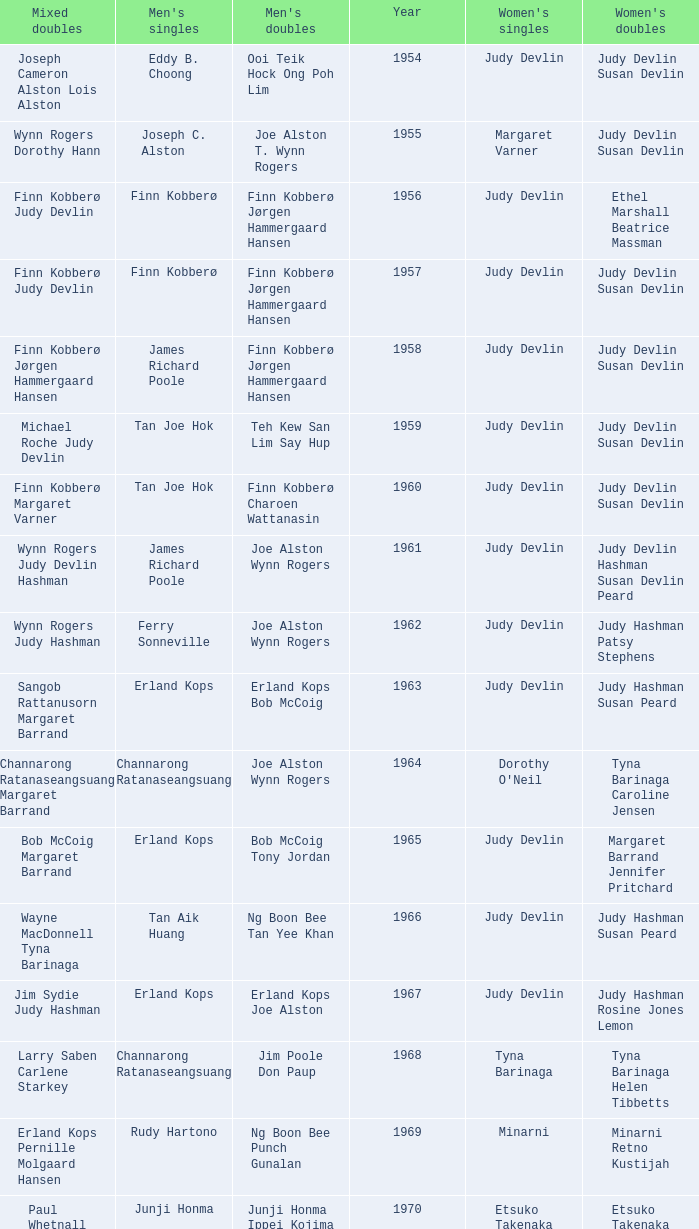Who was the women's singles champion in 1984? Luo Yun. Could you parse the entire table? {'header': ['Mixed doubles', "Men's singles", "Men's doubles", 'Year', "Women's singles", "Women's doubles"], 'rows': [['Joseph Cameron Alston Lois Alston', 'Eddy B. Choong', 'Ooi Teik Hock Ong Poh Lim', '1954', 'Judy Devlin', 'Judy Devlin Susan Devlin'], ['Wynn Rogers Dorothy Hann', 'Joseph C. Alston', 'Joe Alston T. Wynn Rogers', '1955', 'Margaret Varner', 'Judy Devlin Susan Devlin'], ['Finn Kobberø Judy Devlin', 'Finn Kobberø', 'Finn Kobberø Jørgen Hammergaard Hansen', '1956', 'Judy Devlin', 'Ethel Marshall Beatrice Massman'], ['Finn Kobberø Judy Devlin', 'Finn Kobberø', 'Finn Kobberø Jørgen Hammergaard Hansen', '1957', 'Judy Devlin', 'Judy Devlin Susan Devlin'], ['Finn Kobberø Jørgen Hammergaard Hansen', 'James Richard Poole', 'Finn Kobberø Jørgen Hammergaard Hansen', '1958', 'Judy Devlin', 'Judy Devlin Susan Devlin'], ['Michael Roche Judy Devlin', 'Tan Joe Hok', 'Teh Kew San Lim Say Hup', '1959', 'Judy Devlin', 'Judy Devlin Susan Devlin'], ['Finn Kobberø Margaret Varner', 'Tan Joe Hok', 'Finn Kobberø Charoen Wattanasin', '1960', 'Judy Devlin', 'Judy Devlin Susan Devlin'], ['Wynn Rogers Judy Devlin Hashman', 'James Richard Poole', 'Joe Alston Wynn Rogers', '1961', 'Judy Devlin', 'Judy Devlin Hashman Susan Devlin Peard'], ['Wynn Rogers Judy Hashman', 'Ferry Sonneville', 'Joe Alston Wynn Rogers', '1962', 'Judy Devlin', 'Judy Hashman Patsy Stephens'], ['Sangob Rattanusorn Margaret Barrand', 'Erland Kops', 'Erland Kops Bob McCoig', '1963', 'Judy Devlin', 'Judy Hashman Susan Peard'], ['Channarong Ratanaseangsuang Margaret Barrand', 'Channarong Ratanaseangsuang', 'Joe Alston Wynn Rogers', '1964', "Dorothy O'Neil", 'Tyna Barinaga Caroline Jensen'], ['Bob McCoig Margaret Barrand', 'Erland Kops', 'Bob McCoig Tony Jordan', '1965', 'Judy Devlin', 'Margaret Barrand Jennifer Pritchard'], ['Wayne MacDonnell Tyna Barinaga', 'Tan Aik Huang', 'Ng Boon Bee Tan Yee Khan', '1966', 'Judy Devlin', 'Judy Hashman Susan Peard'], ['Jim Sydie Judy Hashman', 'Erland Kops', 'Erland Kops Joe Alston', '1967', 'Judy Devlin', 'Judy Hashman Rosine Jones Lemon'], ['Larry Saben Carlene Starkey', 'Channarong Ratanaseangsuang', 'Jim Poole Don Paup', '1968', 'Tyna Barinaga', 'Tyna Barinaga Helen Tibbetts'], ['Erland Kops Pernille Molgaard Hansen', 'Rudy Hartono', 'Ng Boon Bee Punch Gunalan', '1969', 'Minarni', 'Minarni Retno Kustijah'], ['Paul Whetnall Margaret Boxall', 'Junji Honma', 'Junji Honma Ippei Kojima', '1970', 'Etsuko Takenaka', 'Etsuko Takenaka Machiko Aizawa'], ['Jim Poole Maryanne Breckell', 'Muljadi', 'Ng Boon Bee Punch Gunalan', '1971', 'Noriko Takagi', 'Noriko Takagi Hiroe Yuki'], ['Flemming Delfs Pernille Kaagaard', 'Sture Johnsson', 'Derek Talbot Elliot Stuart', '1972', 'Eva Twedberg', 'Anne Berglund Pernille Kaagaard'], ['Sture Johnsson Eva Twedberg', 'Sture Johnsson', 'Jim Poole Don Paup', '1973', 'Eva Twedberg', 'Pam Brady Diane Hales'], ['no competition', 'no competition', 'no competition', '1974 1975', 'no competition', 'no competition'], ['David Eddy Susan Whetnall', 'Paul Whetnall', 'Willi Braun Roland Maywald', '1976', 'Gillian Gilks', 'Gillian Gilks Susan Whetnall'], ['no competition', 'no competition', 'no competition', '1977 1982', 'no competition', 'no competition'], ['Mike Butler Claire Backhouse', 'Mike Butler', 'John Britton Gary Higgins', '1983', 'Sherrie Liu', 'Claire Backhouse Johanne Falardeau'], ['Wang Pengren Luo Yun', 'Xiong Guobao', 'Chen Hongyong Zhang Qingwu', '1984', 'Luo Yun', 'Yin Haichen Lu Yanahua'], ['Mike Butler Claire Sharpe', 'Mike Butler', 'John Britton Gary Higgins', '1985', 'Claire Backhouse Sharpe', 'Claire Sharpe Sandra Skillings'], ['Mike Butler Johanne Falardeau', 'Sung Han-kuk', 'Yao Ximing Tariq Wadood', '1986', 'Denyse Julien', 'Denyse Julien Johanne Falardeau'], ['Lee Deuk-choon Chung So-young', 'Park Sun-bae', 'Lee Deuk-choon Lee Sang-bok', '1987', 'Chun Suk-sun', 'Kim Ho Ja Chung So-young'], ['Christian Hadinata Ivana Lie', 'Sze Yu', 'Christian Hadinata Lius Pongoh', '1988', 'Lee Myeong-hee', 'Kim Ho Ja Chung So-young'], ['no competition', 'no competition', 'no competition', '1989', 'no competition', 'no competition'], ['Tariq Wadood Traci Britton', 'Fung Permadi', 'Ger Shin-Ming Yang Shih-Jeng', '1990', 'Denyse Julien', 'Denyse Julien Doris Piché'], ['Lee Sang-bok Shim Eun-jung', 'Steve Butler', 'Jalani Sidek Razif Sidek', '1991', 'Shim Eun-jung', 'Shim Eun-jung Kang Bok-seung'], ['Thomas Lund Pernille Dupont', 'Poul-Erik Hoyer-Larsen', 'Cheah Soon Kit Soo Beng Kiang', '1992', 'Lim Xiaoqing', 'Lim Xiaoqing Christine Magnusson'], ['Thomas Lund Catrine Bengtsson', 'Marleve Mainaky', 'Thomas Lund Jon Holst-Christensen', '1993', 'Lim Xiaoqing', 'Gil Young-ah Chung So-young'], ['Jens Eriksen Rikke Olsen', 'Thomas Stuer-Lauridsen', 'Ade Sutrisna Candra Wijaya', '1994', 'Liu Guimei', 'Rikke Olsen Helene Kirkegaard'], ['Kim Dong-moon Gil Young-ah', 'Hermawan Susanto', 'Rudy Gunawan Joko Suprianto', '1995', 'Ye Zhaoying', 'Gil Young-ah Jang Hye-ock'], ['Kim Dong-moon Chung So-young', 'Joko Suprianto', 'Candra Wijaya Sigit Budiarto', '1996', 'Mia Audina', 'Zelin Resiana Eliza Nathanael'], ['Kim Dong Moon Ra Kyung-min', 'Poul-Erik Hoyer-Larsen', 'Ha Tae-kwon Kim Dong-moon', '1997', 'Camilla Martin', 'Qin Yiyuan Tang Yongshu'], ['Kenny Middlemiss Elinor Middlemiss', 'Fung Permadi', 'Horng Shin-Jeng Lee Wei-Jen', '1998', 'Tang Yeping', 'Elinor Middlemiss Kirsteen McEwan'], ['Jonas Rasmussen Jane F. Bramsen', 'Colin Haughton', 'Michael Lamp Jonas Rasmussen', '1999', 'Pi Hongyan', 'Huang Nanyan Lu Ying'], ['Jonas Rasmussen Jane F. Bramsen', 'Ardy Wiranata', 'Graham Hurrell James Anderson', '2000', 'Choi Ma-re', 'Gail Emms Joanne Wright'], ['Mathias Boe Majken Vange', 'Lee Hyun-il', 'Kang Kyung-jin Park Young-duk', '2001', 'Ra Kyung-min', 'Kim Kyeung-ran Ra Kyung-min'], ['Tony Gunawan Etty Tantri', 'Peter Gade', 'Tony Gunawan Khan Malaythong', '2002', 'Julia Mann', 'Joanne Wright Natalie Munt'], ['Tony Gunawan Eti Gunawan', 'Chien Yu-hsiu', 'Tony Gunawan Khan Malaythong', '2003', 'Kelly Morgan', 'Yoshiko Iwata Miyuki Tai'], ['Lin Wei-hsiang Cheng Wen-hsing', 'Kendrick Lee Yen Hui', 'Howard Bach Tony Gunawan', '2004', 'Xing Aiying', 'Cheng Wen-hsing Chien Yu-chin'], ['Khan Malaythong Mesinee Mangkalakiri', 'Hsieh Yu-hsing', 'Howard Bach Tony Gunawan', '2005', 'Lili Zhou', 'Peng Yun Johanna Lee'], ['Sergey Ivlev Nina Vislova', 'Yousuke Nakanishi', 'Halim Haryanto Tony Gunawan', '2006', 'Ella Karachkova', 'Nina Vislova Valeria Sorokina'], ['Keita Masuda Miyuki Maeda', 'Lee Tsuen Seng', 'Tadashi Ohtsuka Keita Masuda', '2007', 'Jun Jae-youn', 'Miyuki Maeda Satoko Suetsuna'], ['Halim Haryanto Peng Yun', 'Andrew Dabeka', 'Howard Bach Khan Malaythong', '2008', 'Lili Zhou', 'Chang Li-Ying Hung Shih-Chieh'], ['Howard Bach Eva Lee', 'Taufik Hidayat', 'Howard Bach Tony Gunawan', '2009', 'Anna Rice', 'Ruilin Huang Xuelian Jiang'], ['Michael Fuchs Birgit Overzier', 'Rajiv Ouseph', 'Fang Chieh-min Lee Sheng-mu', '2010', 'Zhu Lin', 'Cheng Wen-hsing Chien Yu-chin'], ['Lee Yong-dae Ha Jung-eun', 'Sho Sasaki', 'Ko Sung-hyun Lee Yong-dae', '2011', 'Tai Tzu-ying', 'Ha Jung-eun Kim Min-jung'], ['Tony Gunawan Vita Marissa', 'Vladimir Ivanov', 'Hiroyuki Endo Kenichi Hayakawa', '2012', 'Pai Hsiao-ma', 'Misaki Matsutomo Ayaka Takahashi'], ['Lee Chun Hei Chau Hoi Wah', 'Nguyen Tien Minh', 'Takeshi Kamura Keigo Sonoda', '2013', 'Sapsiree Taerattanachai', 'Bao Yixin Zhong Qianxin']]} 